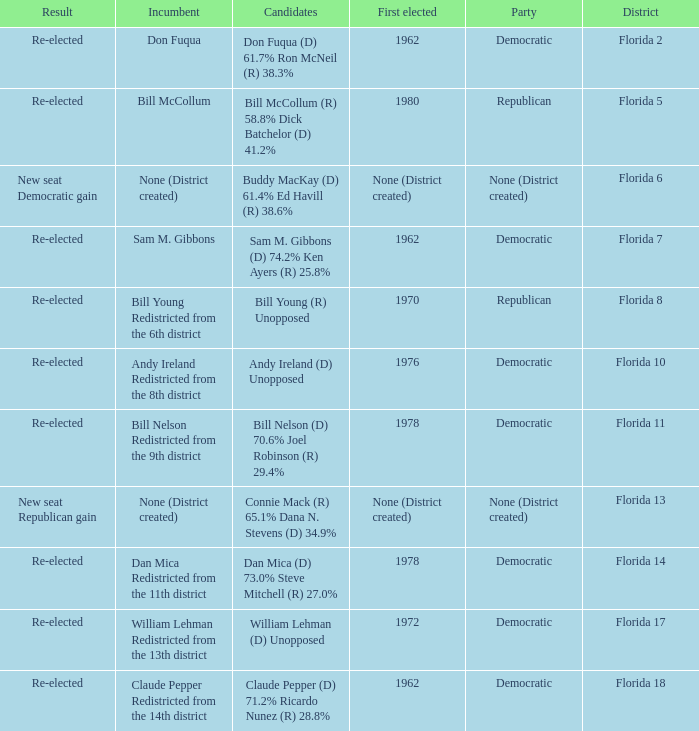Who is the the candidates with incumbent being don fuqua Don Fuqua (D) 61.7% Ron McNeil (R) 38.3%. 